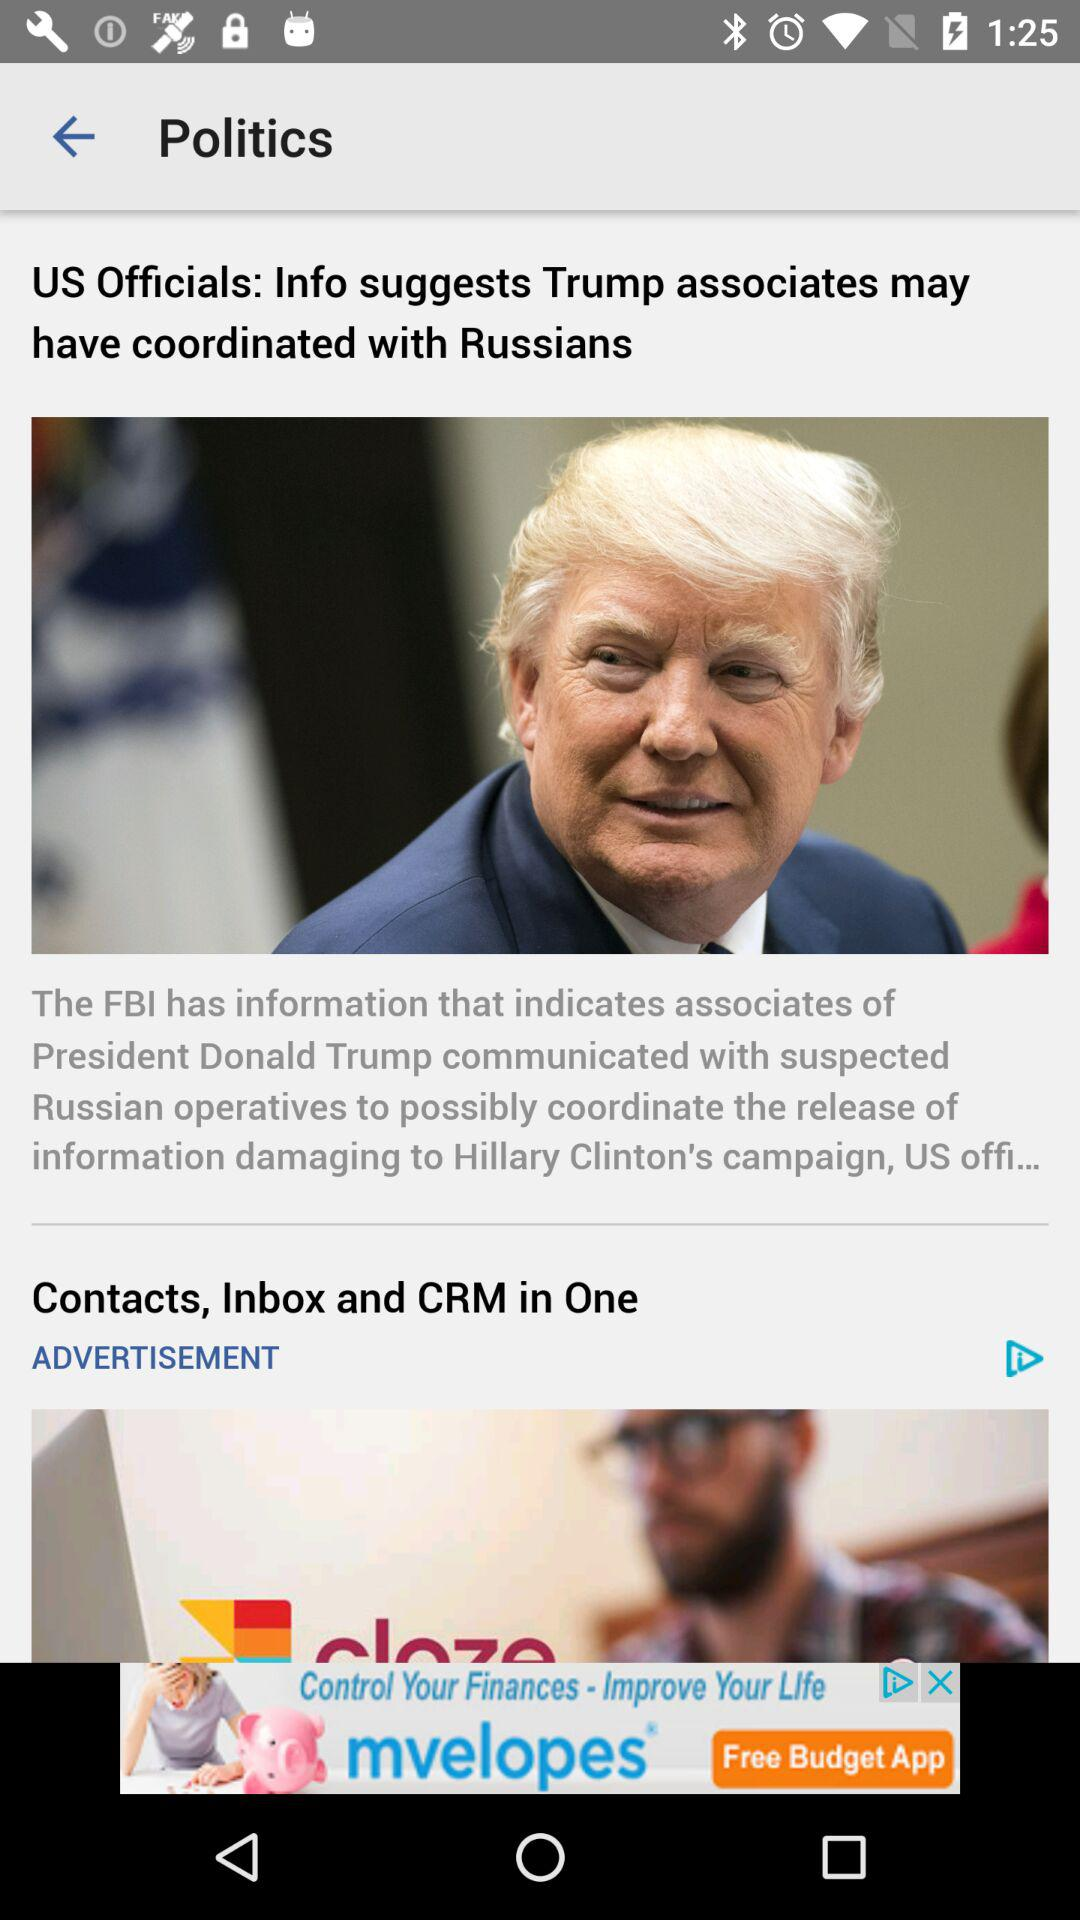What is the headline of the article? The headline is "US Officials: Info suggests Trump associates may have coordinated with Russians". 